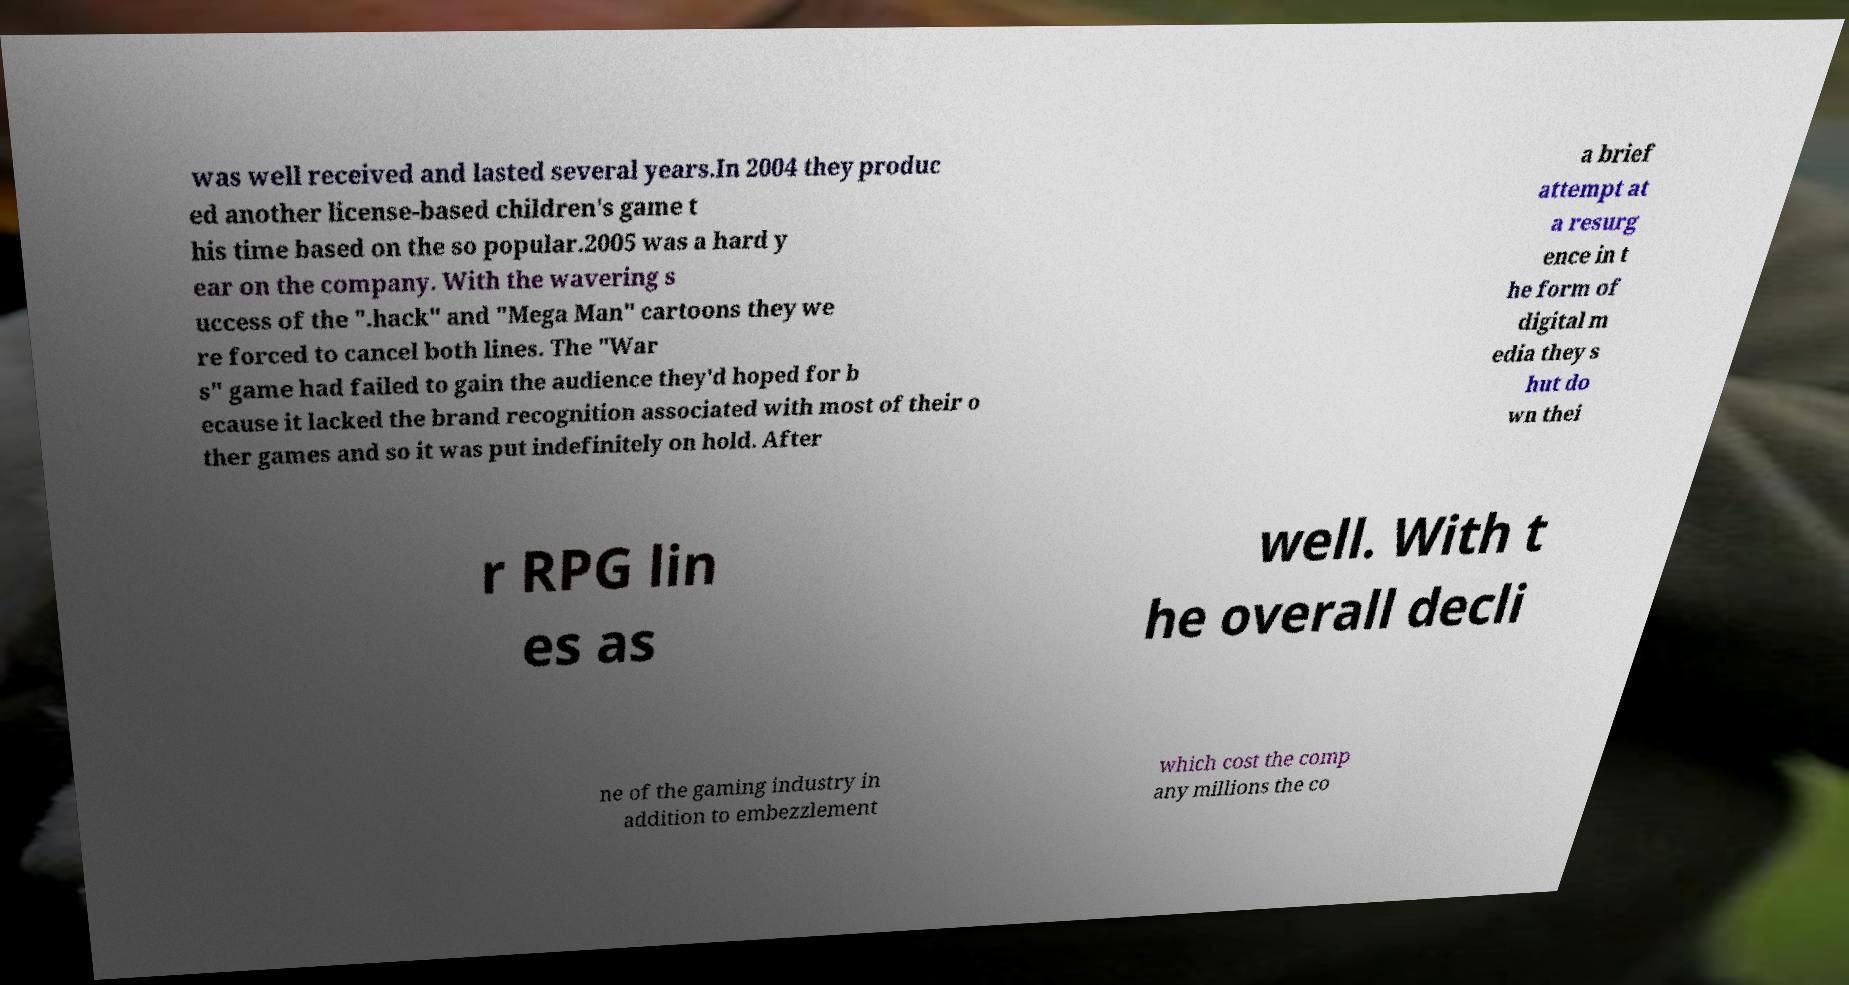There's text embedded in this image that I need extracted. Can you transcribe it verbatim? was well received and lasted several years.In 2004 they produc ed another license-based children's game t his time based on the so popular.2005 was a hard y ear on the company. With the wavering s uccess of the ".hack" and "Mega Man" cartoons they we re forced to cancel both lines. The "War s" game had failed to gain the audience they'd hoped for b ecause it lacked the brand recognition associated with most of their o ther games and so it was put indefinitely on hold. After a brief attempt at a resurg ence in t he form of digital m edia they s hut do wn thei r RPG lin es as well. With t he overall decli ne of the gaming industry in addition to embezzlement which cost the comp any millions the co 